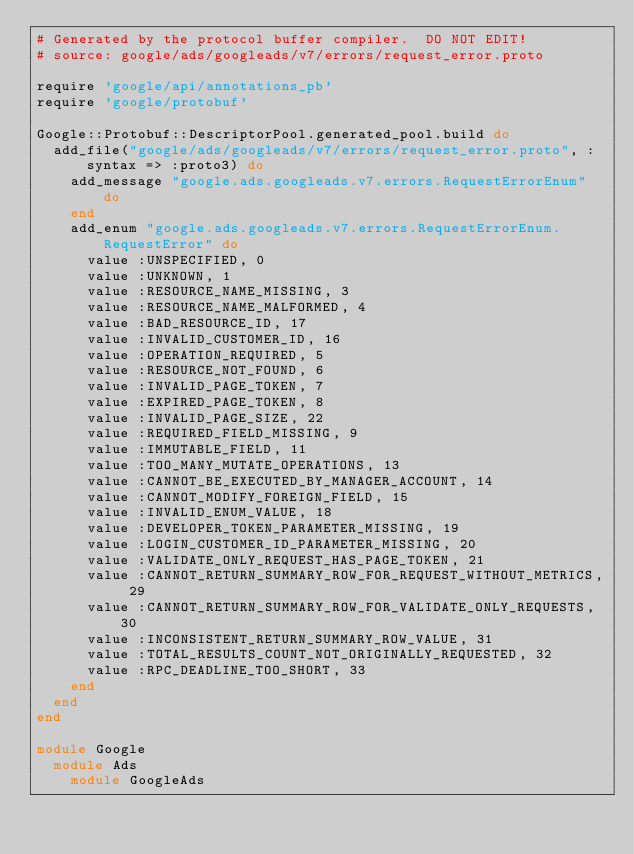Convert code to text. <code><loc_0><loc_0><loc_500><loc_500><_Ruby_># Generated by the protocol buffer compiler.  DO NOT EDIT!
# source: google/ads/googleads/v7/errors/request_error.proto

require 'google/api/annotations_pb'
require 'google/protobuf'

Google::Protobuf::DescriptorPool.generated_pool.build do
  add_file("google/ads/googleads/v7/errors/request_error.proto", :syntax => :proto3) do
    add_message "google.ads.googleads.v7.errors.RequestErrorEnum" do
    end
    add_enum "google.ads.googleads.v7.errors.RequestErrorEnum.RequestError" do
      value :UNSPECIFIED, 0
      value :UNKNOWN, 1
      value :RESOURCE_NAME_MISSING, 3
      value :RESOURCE_NAME_MALFORMED, 4
      value :BAD_RESOURCE_ID, 17
      value :INVALID_CUSTOMER_ID, 16
      value :OPERATION_REQUIRED, 5
      value :RESOURCE_NOT_FOUND, 6
      value :INVALID_PAGE_TOKEN, 7
      value :EXPIRED_PAGE_TOKEN, 8
      value :INVALID_PAGE_SIZE, 22
      value :REQUIRED_FIELD_MISSING, 9
      value :IMMUTABLE_FIELD, 11
      value :TOO_MANY_MUTATE_OPERATIONS, 13
      value :CANNOT_BE_EXECUTED_BY_MANAGER_ACCOUNT, 14
      value :CANNOT_MODIFY_FOREIGN_FIELD, 15
      value :INVALID_ENUM_VALUE, 18
      value :DEVELOPER_TOKEN_PARAMETER_MISSING, 19
      value :LOGIN_CUSTOMER_ID_PARAMETER_MISSING, 20
      value :VALIDATE_ONLY_REQUEST_HAS_PAGE_TOKEN, 21
      value :CANNOT_RETURN_SUMMARY_ROW_FOR_REQUEST_WITHOUT_METRICS, 29
      value :CANNOT_RETURN_SUMMARY_ROW_FOR_VALIDATE_ONLY_REQUESTS, 30
      value :INCONSISTENT_RETURN_SUMMARY_ROW_VALUE, 31
      value :TOTAL_RESULTS_COUNT_NOT_ORIGINALLY_REQUESTED, 32
      value :RPC_DEADLINE_TOO_SHORT, 33
    end
  end
end

module Google
  module Ads
    module GoogleAds</code> 